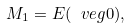Convert formula to latex. <formula><loc_0><loc_0><loc_500><loc_500>M _ { 1 } = E ( \ v e g { 0 } ) ,</formula> 